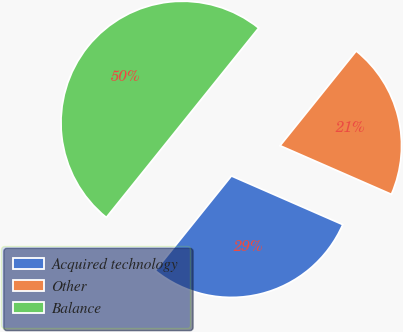Convert chart to OTSL. <chart><loc_0><loc_0><loc_500><loc_500><pie_chart><fcel>Acquired technology<fcel>Other<fcel>Balance<nl><fcel>29.22%<fcel>20.78%<fcel>50.0%<nl></chart> 